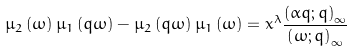Convert formula to latex. <formula><loc_0><loc_0><loc_500><loc_500>\mu _ { 2 } \left ( \omega \right ) \mu _ { 1 } \left ( q \omega \right ) - \mu _ { 2 } \left ( q \omega \right ) \mu _ { 1 } \left ( \omega \right ) = x ^ { \lambda } \frac { \left ( \alpha q ; q \right ) _ { \infty } } { \left ( \omega ; q \right ) _ { \infty } }</formula> 